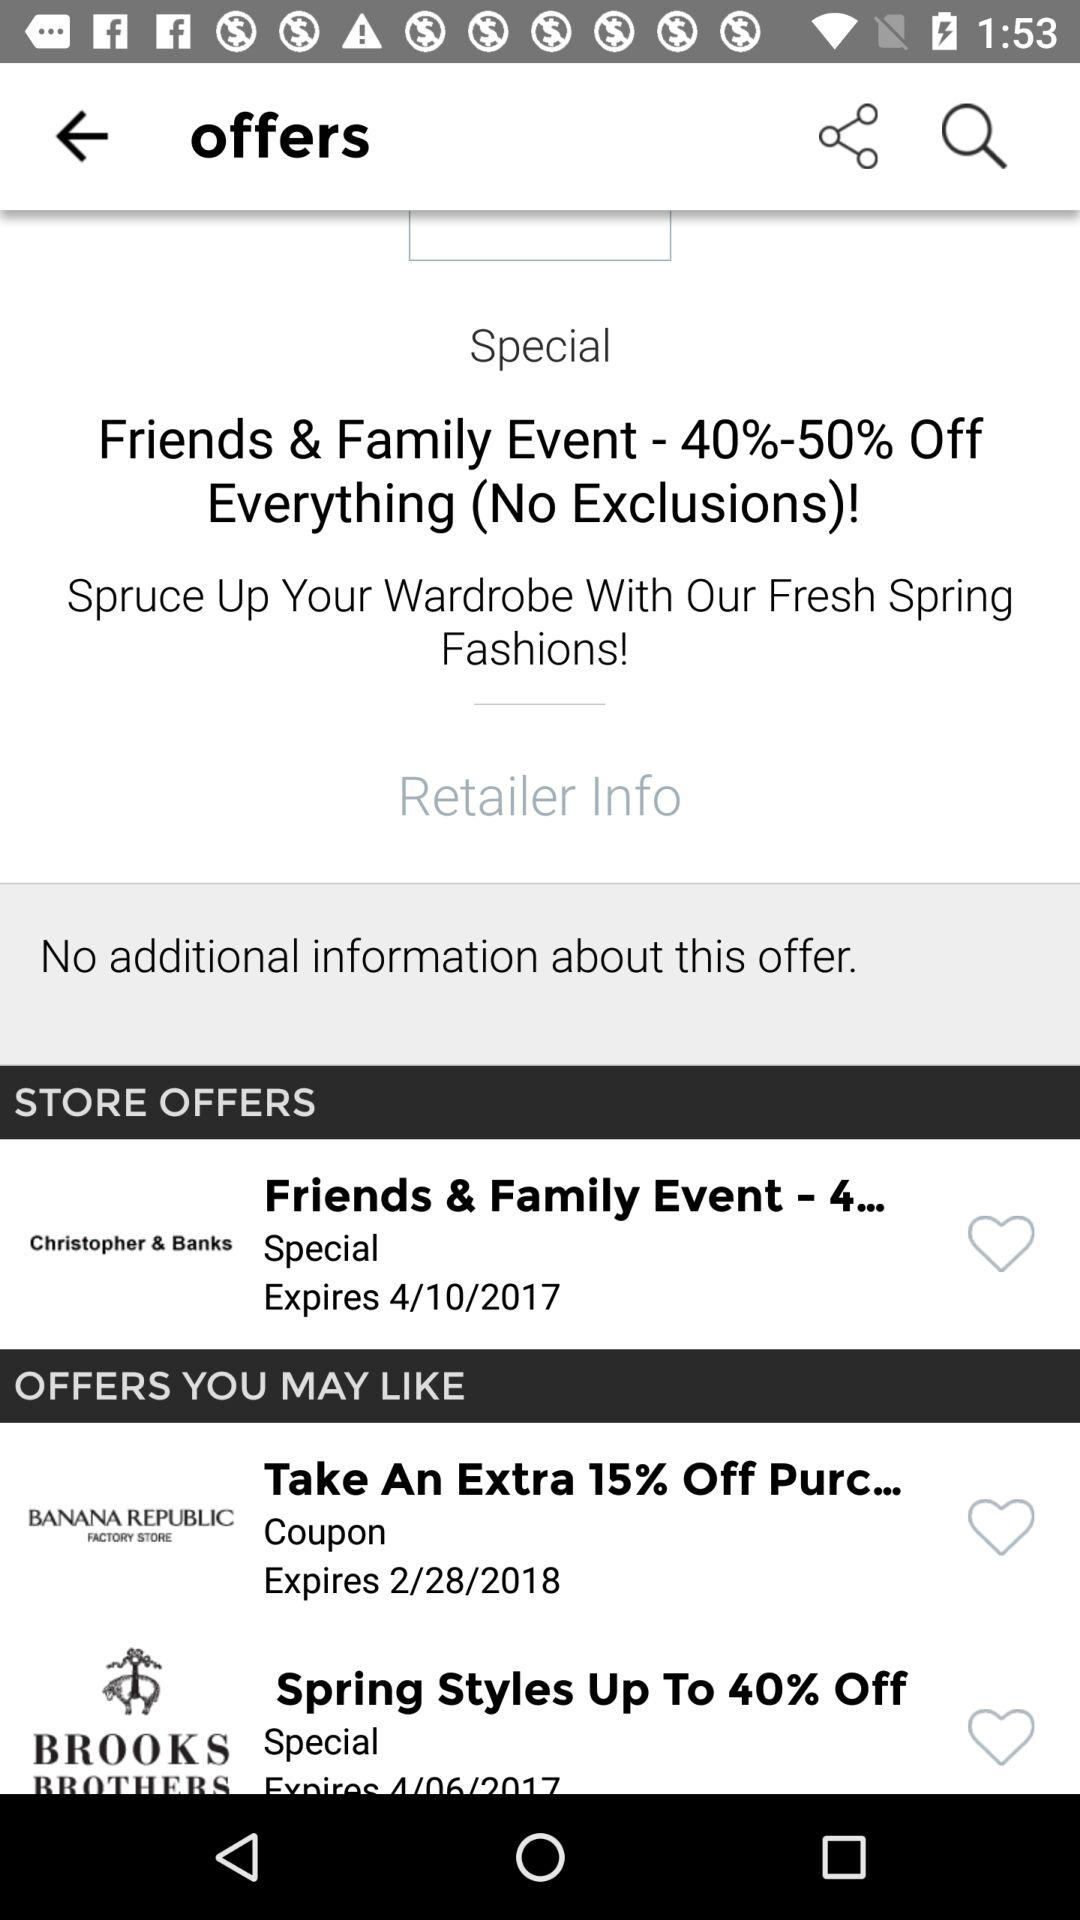Which store give 40 % off?
When the provided information is insufficient, respond with <no answer>. <no answer> 